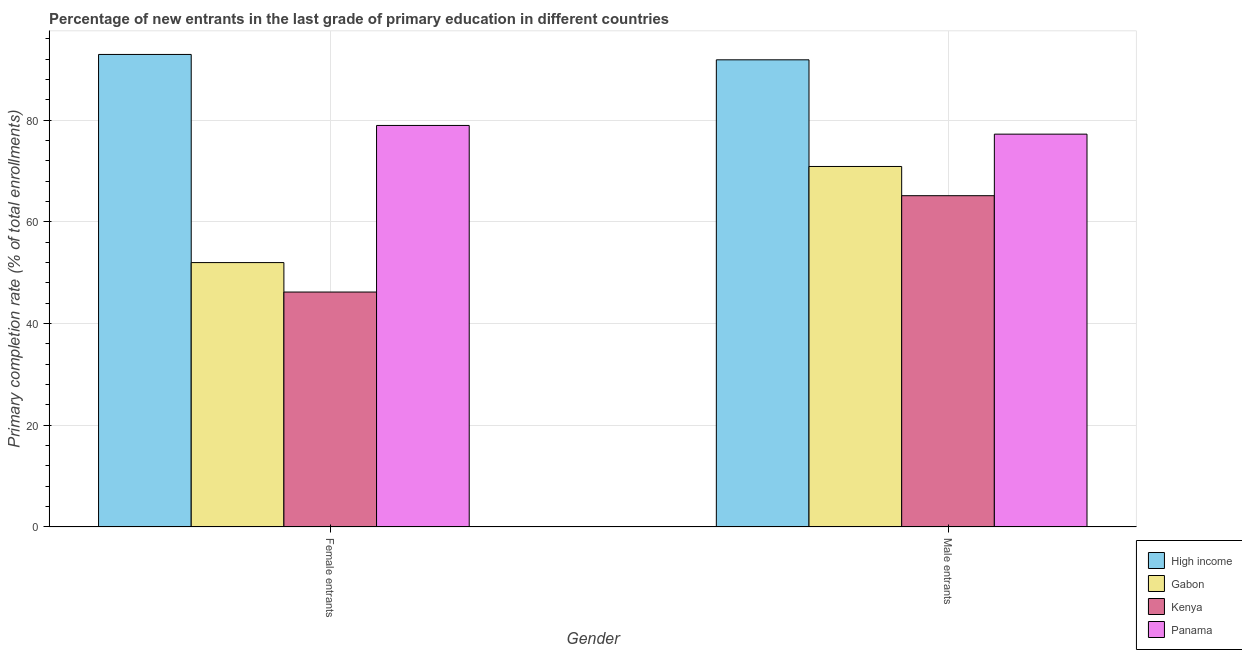Are the number of bars per tick equal to the number of legend labels?
Give a very brief answer. Yes. How many bars are there on the 1st tick from the right?
Give a very brief answer. 4. What is the label of the 1st group of bars from the left?
Offer a very short reply. Female entrants. What is the primary completion rate of female entrants in Kenya?
Make the answer very short. 46.2. Across all countries, what is the maximum primary completion rate of female entrants?
Make the answer very short. 92.92. Across all countries, what is the minimum primary completion rate of male entrants?
Ensure brevity in your answer.  65.15. In which country was the primary completion rate of female entrants minimum?
Give a very brief answer. Kenya. What is the total primary completion rate of male entrants in the graph?
Your response must be concise. 305.16. What is the difference between the primary completion rate of male entrants in Kenya and that in Gabon?
Give a very brief answer. -5.75. What is the difference between the primary completion rate of male entrants in Gabon and the primary completion rate of female entrants in High income?
Offer a terse response. -22.03. What is the average primary completion rate of female entrants per country?
Offer a very short reply. 67.52. What is the difference between the primary completion rate of female entrants and primary completion rate of male entrants in Gabon?
Provide a succinct answer. -18.9. In how many countries, is the primary completion rate of male entrants greater than 64 %?
Provide a short and direct response. 4. What is the ratio of the primary completion rate of male entrants in Gabon to that in High income?
Offer a very short reply. 0.77. Is the primary completion rate of female entrants in Gabon less than that in Panama?
Your answer should be very brief. Yes. What does the 3rd bar from the left in Female entrants represents?
Provide a short and direct response. Kenya. Are all the bars in the graph horizontal?
Give a very brief answer. No. What is the difference between two consecutive major ticks on the Y-axis?
Your answer should be compact. 20. Does the graph contain any zero values?
Provide a short and direct response. No. How many legend labels are there?
Provide a short and direct response. 4. What is the title of the graph?
Offer a terse response. Percentage of new entrants in the last grade of primary education in different countries. Does "Sweden" appear as one of the legend labels in the graph?
Give a very brief answer. No. What is the label or title of the X-axis?
Give a very brief answer. Gender. What is the label or title of the Y-axis?
Your answer should be compact. Primary completion rate (% of total enrollments). What is the Primary completion rate (% of total enrollments) in High income in Female entrants?
Give a very brief answer. 92.92. What is the Primary completion rate (% of total enrollments) in Gabon in Female entrants?
Your answer should be very brief. 51.99. What is the Primary completion rate (% of total enrollments) in Kenya in Female entrants?
Offer a terse response. 46.2. What is the Primary completion rate (% of total enrollments) in Panama in Female entrants?
Offer a terse response. 78.96. What is the Primary completion rate (% of total enrollments) in High income in Male entrants?
Provide a short and direct response. 91.87. What is the Primary completion rate (% of total enrollments) of Gabon in Male entrants?
Offer a very short reply. 70.89. What is the Primary completion rate (% of total enrollments) in Kenya in Male entrants?
Offer a very short reply. 65.15. What is the Primary completion rate (% of total enrollments) of Panama in Male entrants?
Offer a terse response. 77.25. Across all Gender, what is the maximum Primary completion rate (% of total enrollments) of High income?
Give a very brief answer. 92.92. Across all Gender, what is the maximum Primary completion rate (% of total enrollments) in Gabon?
Give a very brief answer. 70.89. Across all Gender, what is the maximum Primary completion rate (% of total enrollments) of Kenya?
Offer a terse response. 65.15. Across all Gender, what is the maximum Primary completion rate (% of total enrollments) of Panama?
Provide a succinct answer. 78.96. Across all Gender, what is the minimum Primary completion rate (% of total enrollments) in High income?
Your response must be concise. 91.87. Across all Gender, what is the minimum Primary completion rate (% of total enrollments) in Gabon?
Provide a short and direct response. 51.99. Across all Gender, what is the minimum Primary completion rate (% of total enrollments) in Kenya?
Provide a succinct answer. 46.2. Across all Gender, what is the minimum Primary completion rate (% of total enrollments) in Panama?
Your answer should be very brief. 77.25. What is the total Primary completion rate (% of total enrollments) in High income in the graph?
Give a very brief answer. 184.79. What is the total Primary completion rate (% of total enrollments) in Gabon in the graph?
Provide a succinct answer. 122.89. What is the total Primary completion rate (% of total enrollments) of Kenya in the graph?
Offer a terse response. 111.35. What is the total Primary completion rate (% of total enrollments) in Panama in the graph?
Provide a succinct answer. 156.21. What is the difference between the Primary completion rate (% of total enrollments) of High income in Female entrants and that in Male entrants?
Offer a very short reply. 1.06. What is the difference between the Primary completion rate (% of total enrollments) in Gabon in Female entrants and that in Male entrants?
Keep it short and to the point. -18.9. What is the difference between the Primary completion rate (% of total enrollments) in Kenya in Female entrants and that in Male entrants?
Offer a very short reply. -18.95. What is the difference between the Primary completion rate (% of total enrollments) in Panama in Female entrants and that in Male entrants?
Offer a very short reply. 1.71. What is the difference between the Primary completion rate (% of total enrollments) in High income in Female entrants and the Primary completion rate (% of total enrollments) in Gabon in Male entrants?
Keep it short and to the point. 22.03. What is the difference between the Primary completion rate (% of total enrollments) of High income in Female entrants and the Primary completion rate (% of total enrollments) of Kenya in Male entrants?
Keep it short and to the point. 27.78. What is the difference between the Primary completion rate (% of total enrollments) in High income in Female entrants and the Primary completion rate (% of total enrollments) in Panama in Male entrants?
Make the answer very short. 15.67. What is the difference between the Primary completion rate (% of total enrollments) of Gabon in Female entrants and the Primary completion rate (% of total enrollments) of Kenya in Male entrants?
Give a very brief answer. -13.15. What is the difference between the Primary completion rate (% of total enrollments) in Gabon in Female entrants and the Primary completion rate (% of total enrollments) in Panama in Male entrants?
Make the answer very short. -25.26. What is the difference between the Primary completion rate (% of total enrollments) of Kenya in Female entrants and the Primary completion rate (% of total enrollments) of Panama in Male entrants?
Offer a very short reply. -31.05. What is the average Primary completion rate (% of total enrollments) of High income per Gender?
Offer a very short reply. 92.39. What is the average Primary completion rate (% of total enrollments) in Gabon per Gender?
Offer a very short reply. 61.44. What is the average Primary completion rate (% of total enrollments) in Kenya per Gender?
Give a very brief answer. 55.67. What is the average Primary completion rate (% of total enrollments) in Panama per Gender?
Your answer should be compact. 78.11. What is the difference between the Primary completion rate (% of total enrollments) of High income and Primary completion rate (% of total enrollments) of Gabon in Female entrants?
Provide a succinct answer. 40.93. What is the difference between the Primary completion rate (% of total enrollments) in High income and Primary completion rate (% of total enrollments) in Kenya in Female entrants?
Provide a succinct answer. 46.72. What is the difference between the Primary completion rate (% of total enrollments) in High income and Primary completion rate (% of total enrollments) in Panama in Female entrants?
Provide a short and direct response. 13.96. What is the difference between the Primary completion rate (% of total enrollments) in Gabon and Primary completion rate (% of total enrollments) in Kenya in Female entrants?
Ensure brevity in your answer.  5.79. What is the difference between the Primary completion rate (% of total enrollments) in Gabon and Primary completion rate (% of total enrollments) in Panama in Female entrants?
Keep it short and to the point. -26.97. What is the difference between the Primary completion rate (% of total enrollments) in Kenya and Primary completion rate (% of total enrollments) in Panama in Female entrants?
Offer a terse response. -32.76. What is the difference between the Primary completion rate (% of total enrollments) in High income and Primary completion rate (% of total enrollments) in Gabon in Male entrants?
Offer a terse response. 20.97. What is the difference between the Primary completion rate (% of total enrollments) in High income and Primary completion rate (% of total enrollments) in Kenya in Male entrants?
Offer a very short reply. 26.72. What is the difference between the Primary completion rate (% of total enrollments) of High income and Primary completion rate (% of total enrollments) of Panama in Male entrants?
Give a very brief answer. 14.62. What is the difference between the Primary completion rate (% of total enrollments) of Gabon and Primary completion rate (% of total enrollments) of Kenya in Male entrants?
Your response must be concise. 5.75. What is the difference between the Primary completion rate (% of total enrollments) in Gabon and Primary completion rate (% of total enrollments) in Panama in Male entrants?
Offer a very short reply. -6.36. What is the difference between the Primary completion rate (% of total enrollments) in Kenya and Primary completion rate (% of total enrollments) in Panama in Male entrants?
Your answer should be very brief. -12.11. What is the ratio of the Primary completion rate (% of total enrollments) in High income in Female entrants to that in Male entrants?
Provide a succinct answer. 1.01. What is the ratio of the Primary completion rate (% of total enrollments) in Gabon in Female entrants to that in Male entrants?
Your response must be concise. 0.73. What is the ratio of the Primary completion rate (% of total enrollments) in Kenya in Female entrants to that in Male entrants?
Offer a very short reply. 0.71. What is the ratio of the Primary completion rate (% of total enrollments) of Panama in Female entrants to that in Male entrants?
Give a very brief answer. 1.02. What is the difference between the highest and the second highest Primary completion rate (% of total enrollments) of High income?
Your answer should be compact. 1.06. What is the difference between the highest and the second highest Primary completion rate (% of total enrollments) of Gabon?
Offer a very short reply. 18.9. What is the difference between the highest and the second highest Primary completion rate (% of total enrollments) of Kenya?
Provide a succinct answer. 18.95. What is the difference between the highest and the second highest Primary completion rate (% of total enrollments) of Panama?
Offer a terse response. 1.71. What is the difference between the highest and the lowest Primary completion rate (% of total enrollments) of High income?
Offer a very short reply. 1.06. What is the difference between the highest and the lowest Primary completion rate (% of total enrollments) of Gabon?
Give a very brief answer. 18.9. What is the difference between the highest and the lowest Primary completion rate (% of total enrollments) in Kenya?
Your response must be concise. 18.95. What is the difference between the highest and the lowest Primary completion rate (% of total enrollments) of Panama?
Offer a terse response. 1.71. 